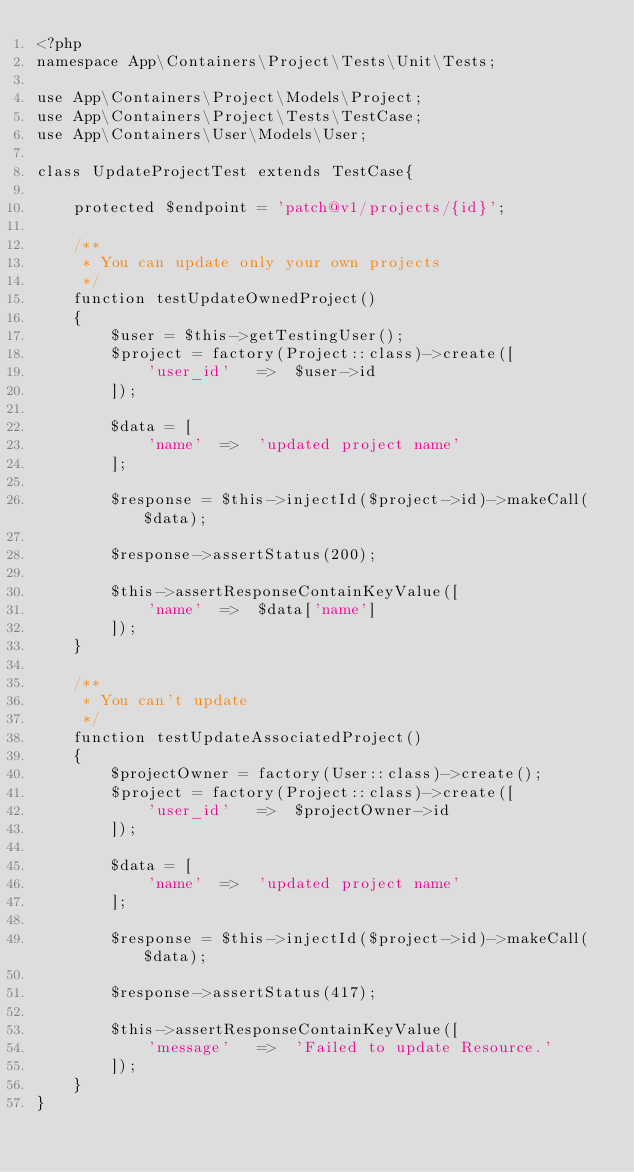Convert code to text. <code><loc_0><loc_0><loc_500><loc_500><_PHP_><?php
namespace App\Containers\Project\Tests\Unit\Tests;

use App\Containers\Project\Models\Project;
use App\Containers\Project\Tests\TestCase;
use App\Containers\User\Models\User;

class UpdateProjectTest extends TestCase{

    protected $endpoint = 'patch@v1/projects/{id}';

    /**
     * You can update only your own projects
     */
    function testUpdateOwnedProject()
    {
        $user = $this->getTestingUser();
        $project = factory(Project::class)->create([
            'user_id'   =>  $user->id
        ]);

        $data = [
            'name'  =>  'updated project name'
        ];

        $response = $this->injectId($project->id)->makeCall($data);

        $response->assertStatus(200);

        $this->assertResponseContainKeyValue([
            'name'  =>  $data['name']
        ]);
    }

    /**
     * You can't update
     */
    function testUpdateAssociatedProject()
    {
        $projectOwner = factory(User::class)->create();
        $project = factory(Project::class)->create([
            'user_id'   =>  $projectOwner->id
        ]);

        $data = [
            'name'  =>  'updated project name'
        ];

        $response = $this->injectId($project->id)->makeCall($data);

        $response->assertStatus(417);

        $this->assertResponseContainKeyValue([
            'message'   =>  'Failed to update Resource.'
        ]);
    }
}</code> 